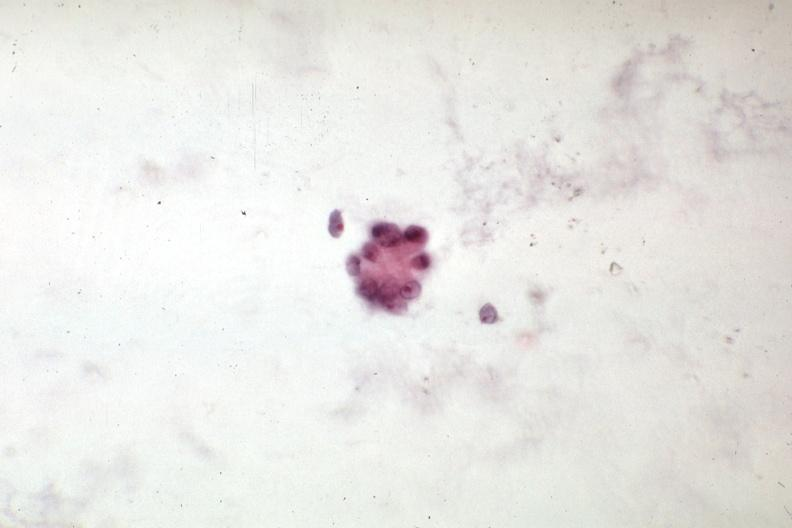s leiomyosarcoma present?
Answer the question using a single word or phrase. No 